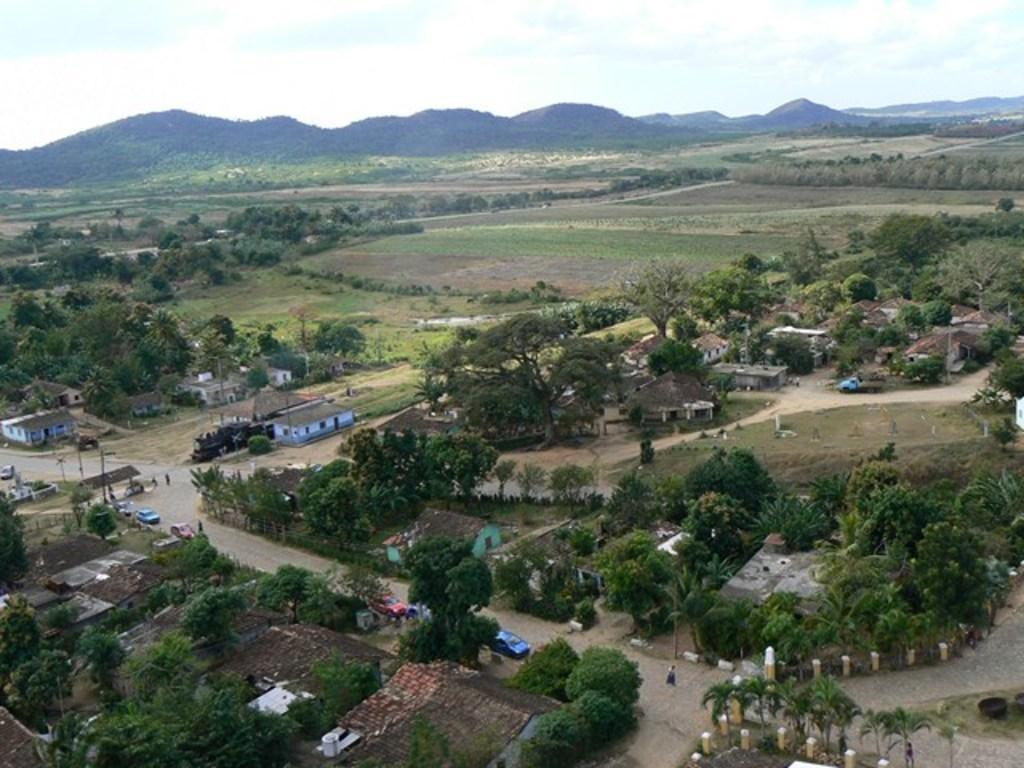How would you summarize this image in a sentence or two? This is an aerial view, in this image there are houses, trees, cars on roads, in the background there are fields, mountains and the sky. 